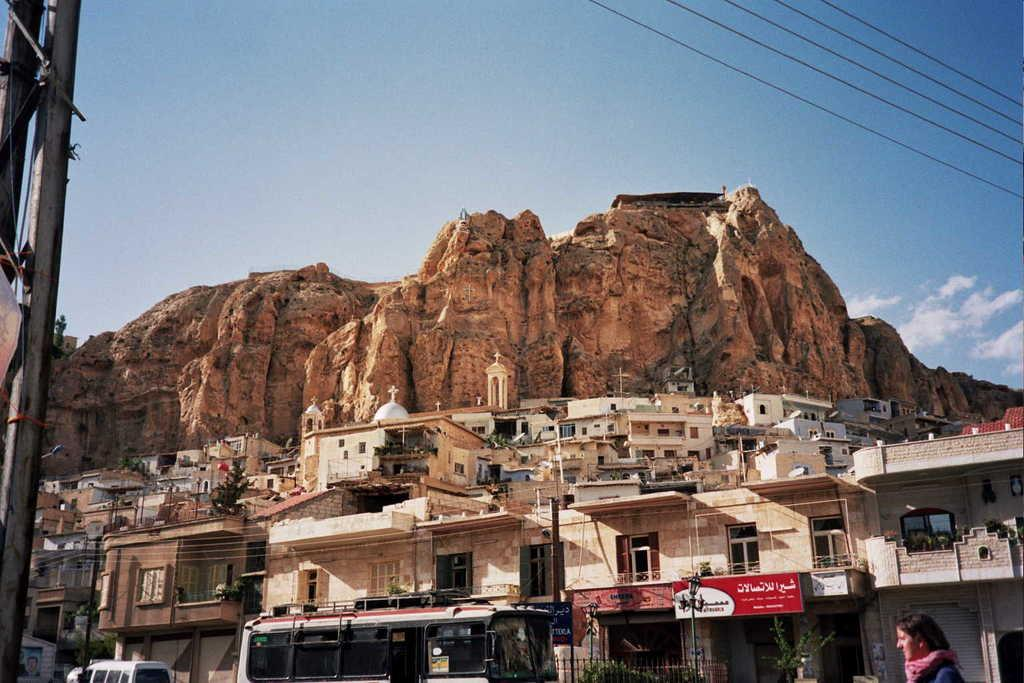What type of structures can be seen in the image? There are buildings in the image. What is happening on the road in the image? Vehicles are moving on the road in the image. Can you describe the person in the image? There is a lady in the image. What are the vertical structures in the image? There are poles in the image. What can be seen in the background of the image? There are mountains and the sky visible in the background of the image. What type of religious amusement can be seen in the sky in the image? There is no religious amusement present in the image, nor is there any indication of amusement or anything related to the sky in the image. 